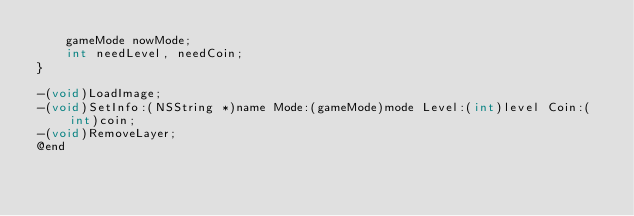Convert code to text. <code><loc_0><loc_0><loc_500><loc_500><_C_>    gameMode nowMode;
    int needLevel, needCoin;
}

-(void)LoadImage;
-(void)SetInfo:(NSString *)name Mode:(gameMode)mode Level:(int)level Coin:(int)coin;
-(void)RemoveLayer;
@end
</code> 